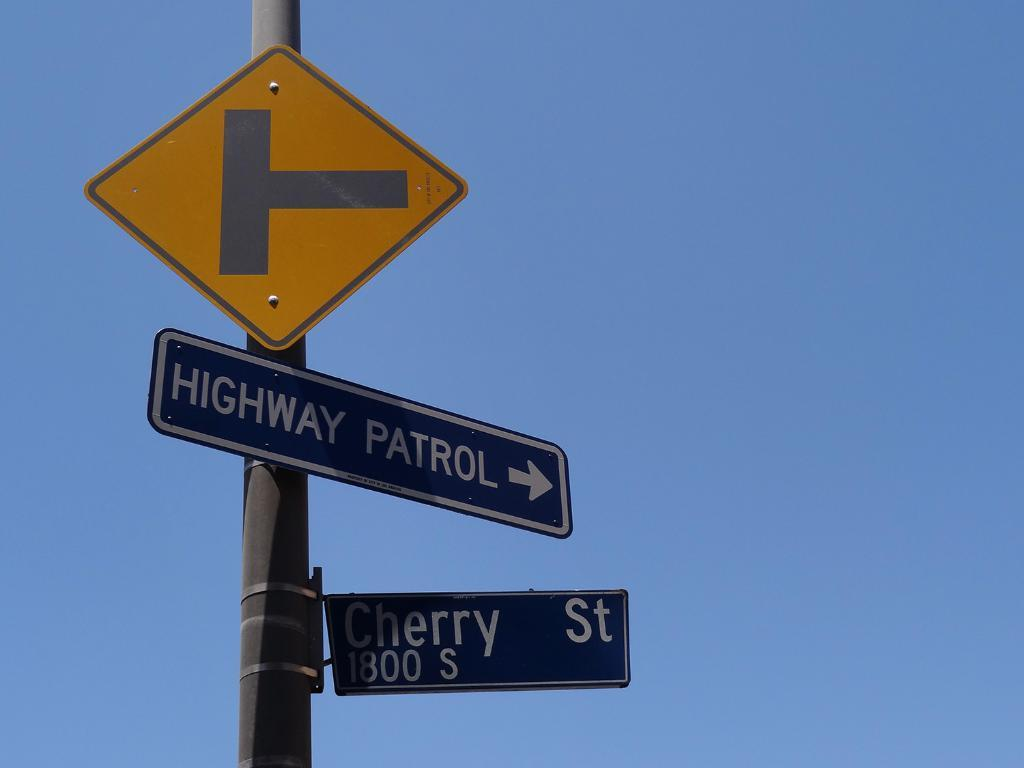<image>
Relay a brief, clear account of the picture shown. A road sign showing the way to the Highway Patrol and CHerry St. 